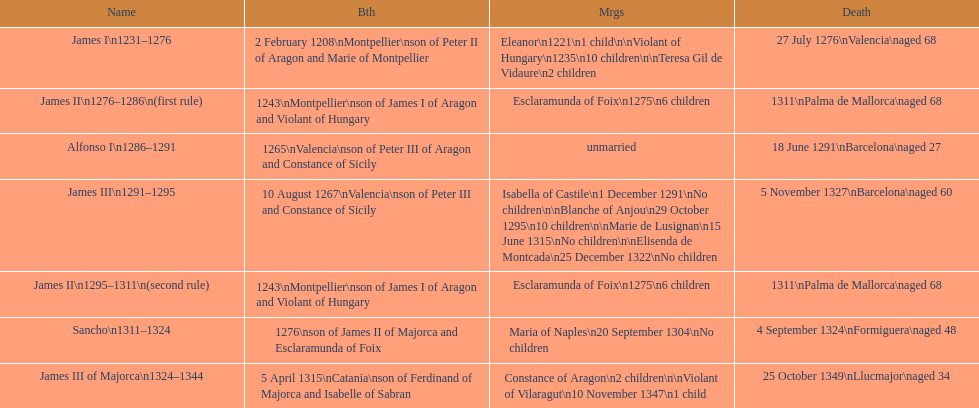How many of these monarchs died before the age of 65? 4. 